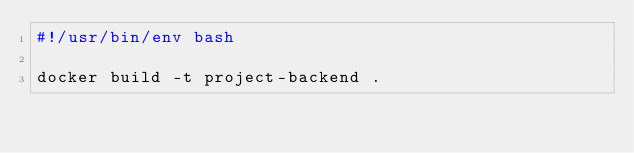Convert code to text. <code><loc_0><loc_0><loc_500><loc_500><_Bash_>#!/usr/bin/env bash

docker build -t project-backend .
</code> 